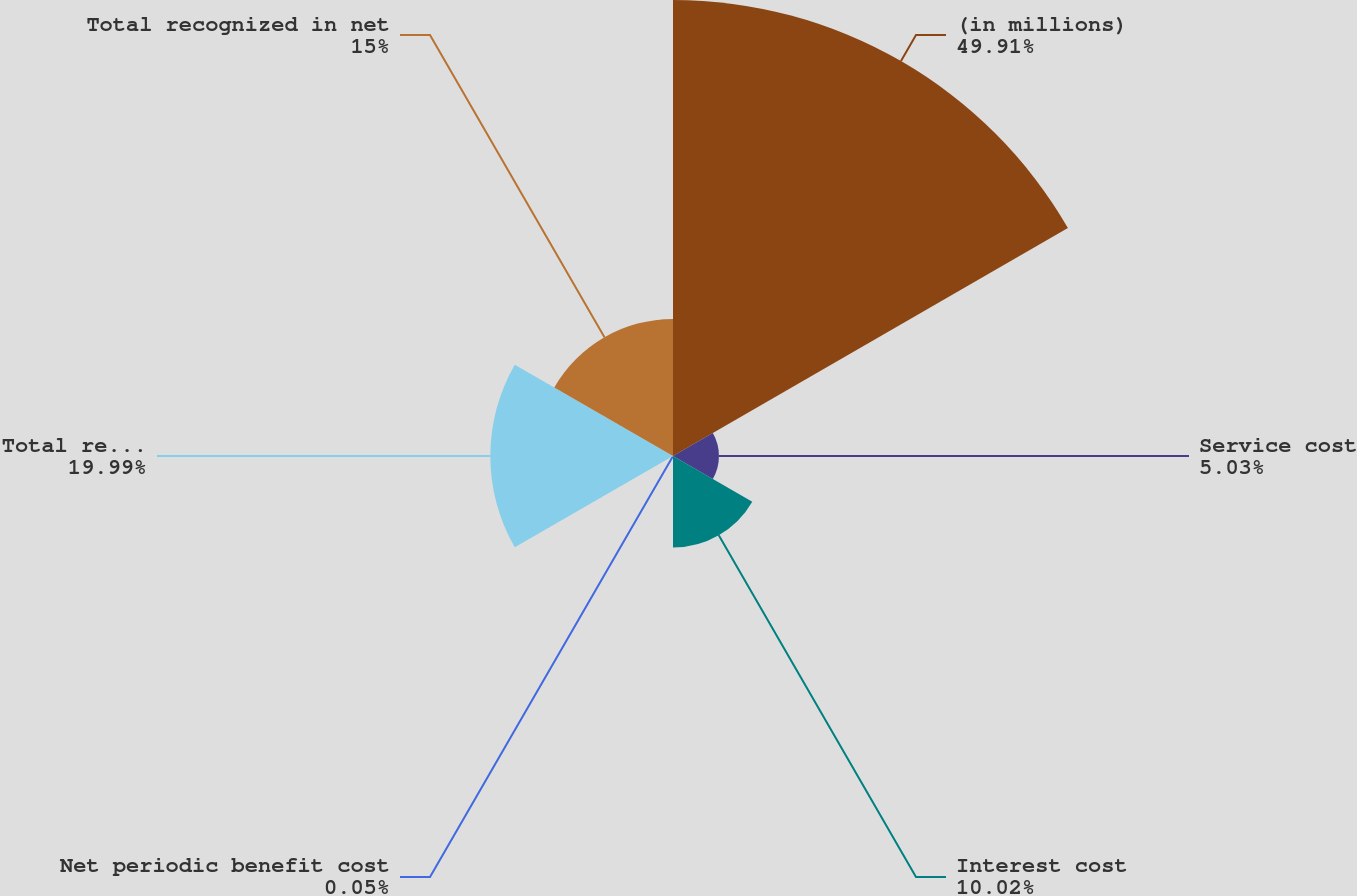Convert chart. <chart><loc_0><loc_0><loc_500><loc_500><pie_chart><fcel>(in millions)<fcel>Service cost<fcel>Interest cost<fcel>Net periodic benefit cost<fcel>Total recognized in<fcel>Total recognized in net<nl><fcel>49.9%<fcel>5.03%<fcel>10.02%<fcel>0.05%<fcel>19.99%<fcel>15.0%<nl></chart> 